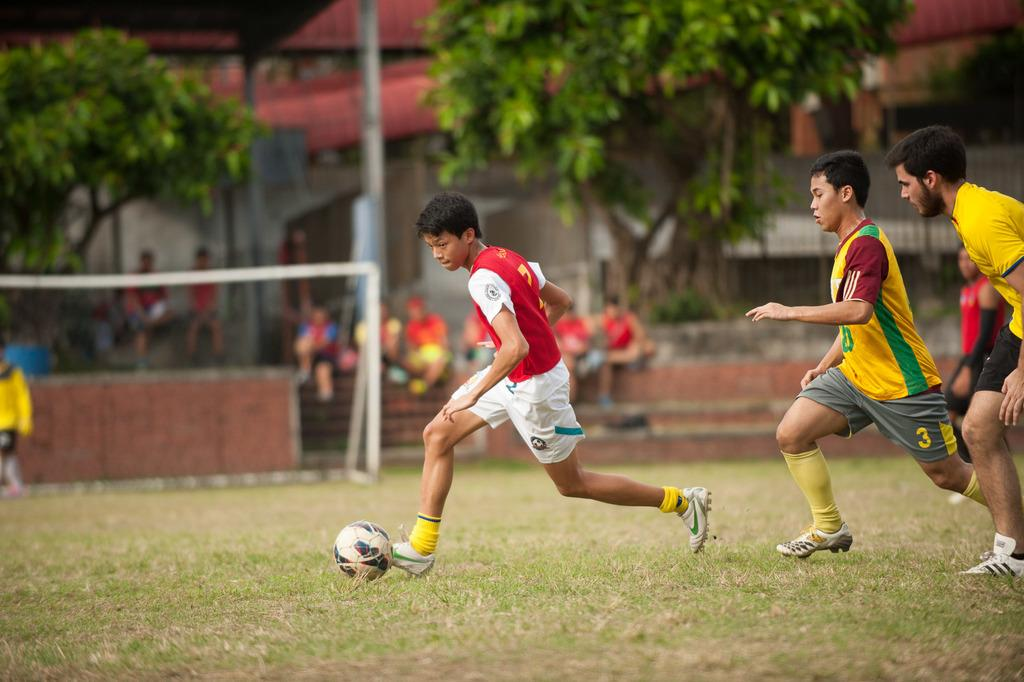Who is present in the image? There is a group of men in the image. What are the men doing in the image? The men are playing football. What can be seen in the background of the image? There are trees visible in the image. What type of structure is present in the image? There is a building in the image. What type of lizards can be seen participating in the discussion in the image? There are no lizards or discussions present in the image; it features a group of men playing football. What room are the men in while playing football in the image? The image does not specify a room, as it appears to be an outdoor setting with trees and a building visible in the background. 